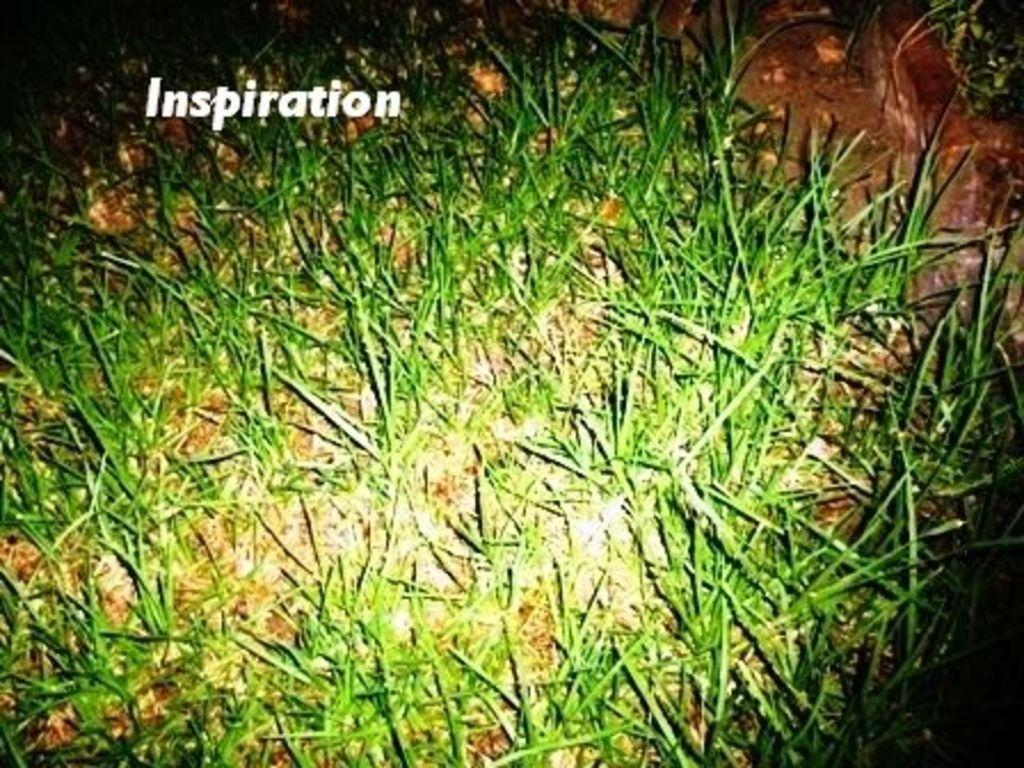What type of vegetation can be seen in the image? There is grass in the image. What other element can be seen on the ground in the image? There is mud visible in the image. Is there any text present in the image? Yes, there is a text on the grass in the image. What type of mint can be seen growing in the image? There is no mint plant visible in the image; it only features grass and mud. Can you describe how the mud is being smashed in the image? There is no indication of any smashing action in the image; the mud is simply visible on the ground. 